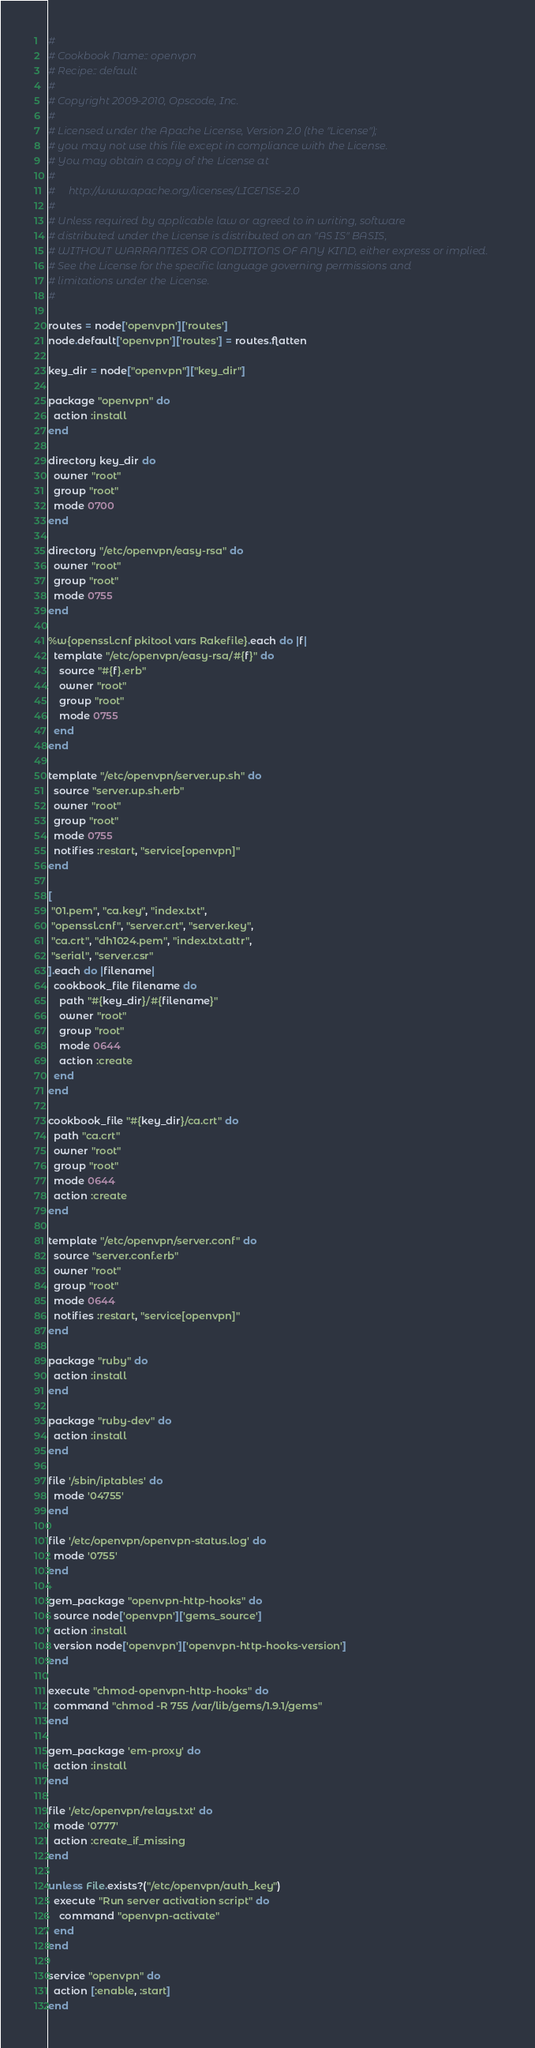<code> <loc_0><loc_0><loc_500><loc_500><_Ruby_>#
# Cookbook Name:: openvpn
# Recipe:: default
#
# Copyright 2009-2010, Opscode, Inc.
#
# Licensed under the Apache License, Version 2.0 (the "License");
# you may not use this file except in compliance with the License.
# You may obtain a copy of the License at
#
#     http://www.apache.org/licenses/LICENSE-2.0
#
# Unless required by applicable law or agreed to in writing, software
# distributed under the License is distributed on an "AS IS" BASIS,
# WITHOUT WARRANTIES OR CONDITIONS OF ANY KIND, either express or implied.
# See the License for the specific language governing permissions and
# limitations under the License.
#

routes = node['openvpn']['routes']
node.default['openvpn']['routes'] = routes.flatten

key_dir = node["openvpn"]["key_dir"]

package "openvpn" do
  action :install
end

directory key_dir do
  owner "root"
  group "root"
  mode 0700
end

directory "/etc/openvpn/easy-rsa" do
  owner "root"
  group "root"
  mode 0755
end

%w{openssl.cnf pkitool vars Rakefile}.each do |f|
  template "/etc/openvpn/easy-rsa/#{f}" do
    source "#{f}.erb"
    owner "root"
    group "root"
    mode 0755
  end
end

template "/etc/openvpn/server.up.sh" do
  source "server.up.sh.erb"
  owner "root"
  group "root"
  mode 0755
  notifies :restart, "service[openvpn]"
end

[
 "01.pem", "ca.key", "index.txt",
 "openssl.cnf", "server.crt", "server.key",
 "ca.crt", "dh1024.pem", "index.txt.attr",
 "serial", "server.csr"
].each do |filename|
  cookbook_file filename do
    path "#{key_dir}/#{filename}"
    owner "root"
    group "root"
    mode 0644
    action :create
  end
end

cookbook_file "#{key_dir}/ca.crt" do
  path "ca.crt"
  owner "root"
  group "root"
  mode 0644
  action :create
end

template "/etc/openvpn/server.conf" do
  source "server.conf.erb"
  owner "root"
  group "root"
  mode 0644
  notifies :restart, "service[openvpn]"
end

package "ruby" do
  action :install
end

package "ruby-dev" do
  action :install
end

file '/sbin/iptables' do
  mode '04755'
end

file '/etc/openvpn/openvpn-status.log' do
  mode '0755'
end

gem_package "openvpn-http-hooks" do
  source node['openvpn']['gems_source']
  action :install
  version node['openvpn']['openvpn-http-hooks-version']
end

execute "chmod-openvpn-http-hooks" do
  command "chmod -R 755 /var/lib/gems/1.9.1/gems"
end

gem_package 'em-proxy' do
  action :install
end

file '/etc/openvpn/relays.txt' do
  mode '0777'
  action :create_if_missing
end

unless File.exists?("/etc/openvpn/auth_key")
  execute "Run server activation script" do
    command "openvpn-activate"
  end
end

service "openvpn" do
  action [:enable, :start]
end
</code> 